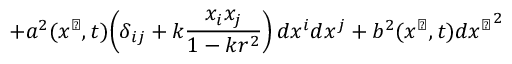<formula> <loc_0><loc_0><loc_500><loc_500>+ a ^ { 2 } ( x ^ { \perp } , t ) \, \left ( \delta _ { i j } + k \frac { x _ { i } x _ { j } } { 1 - k r ^ { 2 } } \right ) d x ^ { i } d x ^ { j } + b ^ { 2 } ( x ^ { \perp } , t ) d { x ^ { \perp } } ^ { 2 }</formula> 